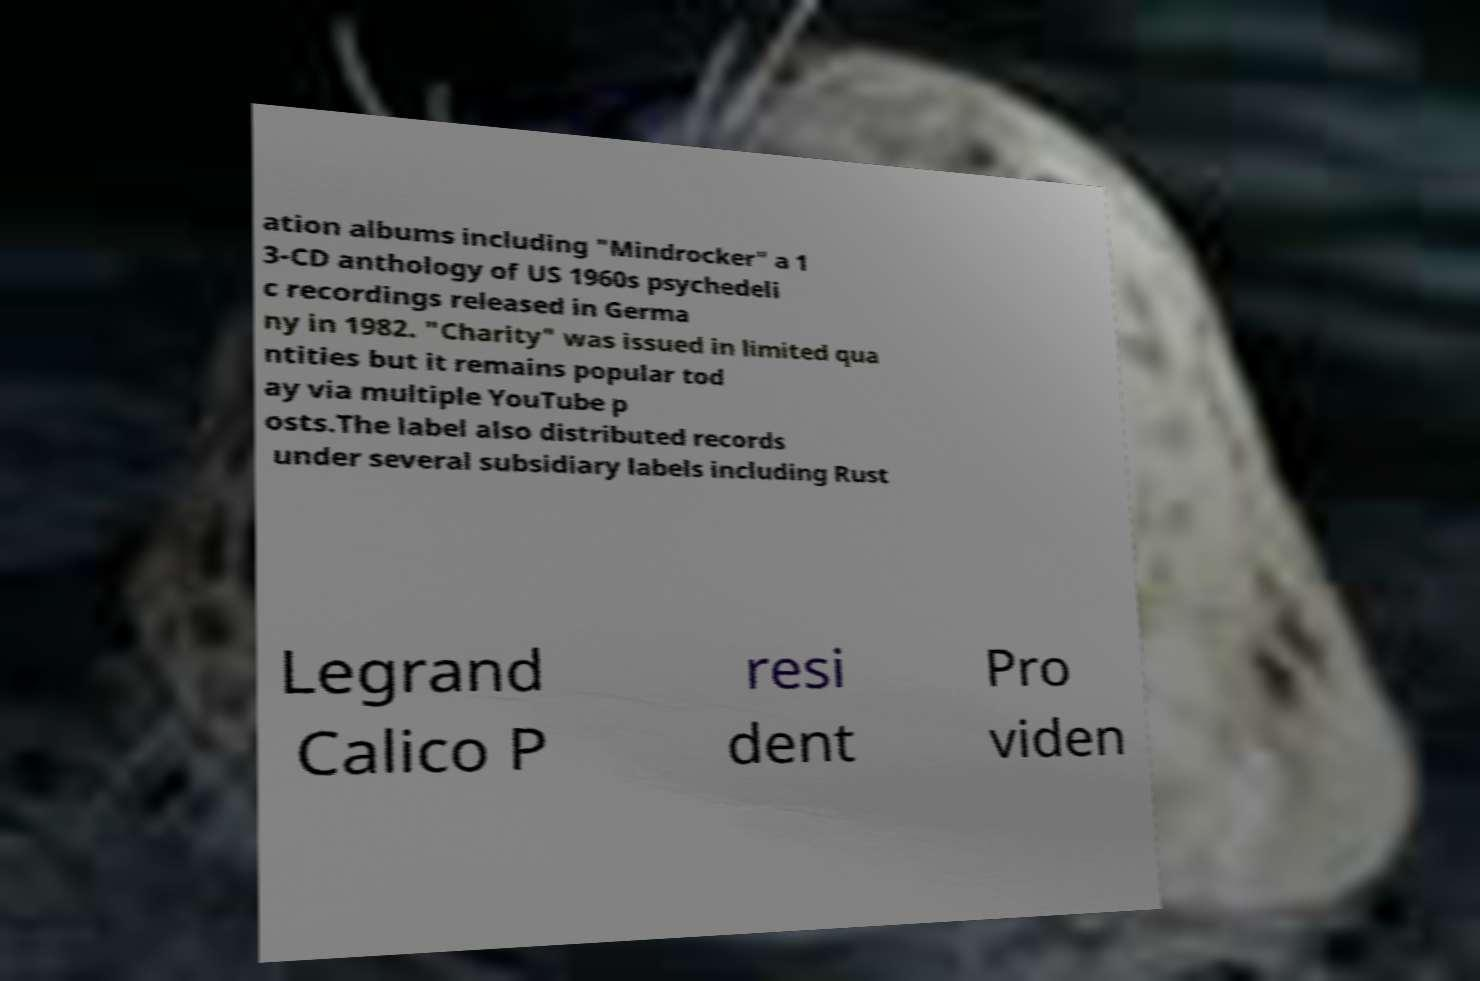I need the written content from this picture converted into text. Can you do that? ation albums including "Mindrocker" a 1 3-CD anthology of US 1960s psychedeli c recordings released in Germa ny in 1982. "Charity" was issued in limited qua ntities but it remains popular tod ay via multiple YouTube p osts.The label also distributed records under several subsidiary labels including Rust Legrand Calico P resi dent Pro viden 